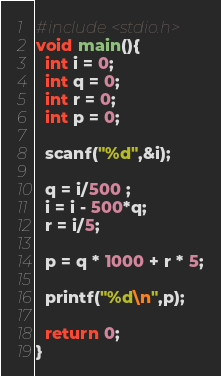<code> <loc_0><loc_0><loc_500><loc_500><_C_>#include<stdio.h>
void main(){
  int i = 0;
  int q = 0;
  int r = 0;
  int p = 0;

  scanf("%d",&i);

  q = i/500 ;
  i = i - 500*q;
  r = i/5;

  p = q * 1000 + r * 5;

  printf("%d\n",p);

  return 0;
}
</code> 